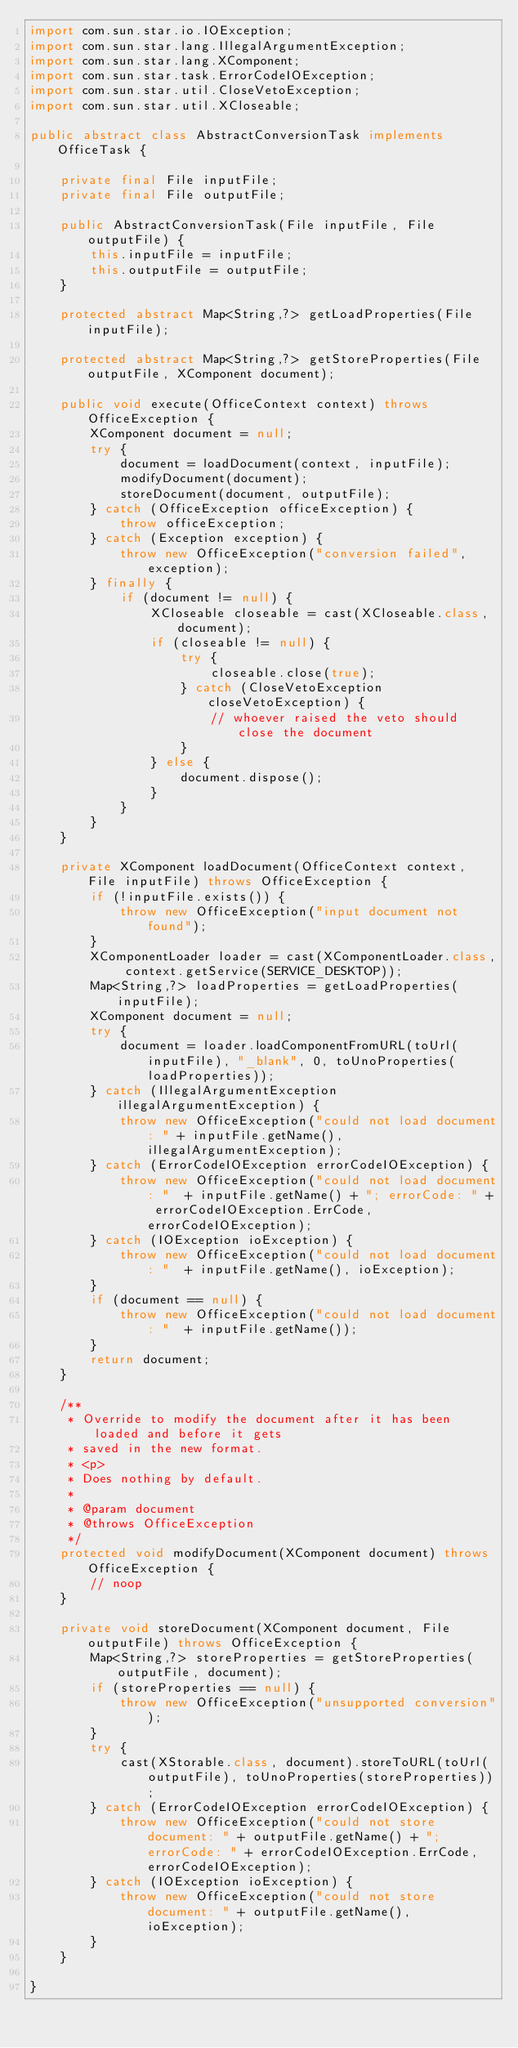<code> <loc_0><loc_0><loc_500><loc_500><_Java_>import com.sun.star.io.IOException;
import com.sun.star.lang.IllegalArgumentException;
import com.sun.star.lang.XComponent;
import com.sun.star.task.ErrorCodeIOException;
import com.sun.star.util.CloseVetoException;
import com.sun.star.util.XCloseable;

public abstract class AbstractConversionTask implements OfficeTask {

    private final File inputFile;
    private final File outputFile;

    public AbstractConversionTask(File inputFile, File outputFile) {
        this.inputFile = inputFile;
        this.outputFile = outputFile;
    }

    protected abstract Map<String,?> getLoadProperties(File inputFile);

    protected abstract Map<String,?> getStoreProperties(File outputFile, XComponent document);

    public void execute(OfficeContext context) throws OfficeException {
        XComponent document = null;
        try {
            document = loadDocument(context, inputFile);
            modifyDocument(document);
            storeDocument(document, outputFile);
        } catch (OfficeException officeException) {
            throw officeException;
        } catch (Exception exception) {
            throw new OfficeException("conversion failed", exception);
        } finally {
            if (document != null) {
                XCloseable closeable = cast(XCloseable.class, document);
                if (closeable != null) {
                    try {
                        closeable.close(true);
                    } catch (CloseVetoException closeVetoException) {
                        // whoever raised the veto should close the document
                    }
                } else {
                    document.dispose();
                }
            }
        }
    }

    private XComponent loadDocument(OfficeContext context, File inputFile) throws OfficeException {
        if (!inputFile.exists()) {
            throw new OfficeException("input document not found");
        }
        XComponentLoader loader = cast(XComponentLoader.class, context.getService(SERVICE_DESKTOP));
        Map<String,?> loadProperties = getLoadProperties(inputFile);
        XComponent document = null;
        try {
            document = loader.loadComponentFromURL(toUrl(inputFile), "_blank", 0, toUnoProperties(loadProperties));
        } catch (IllegalArgumentException illegalArgumentException) {
            throw new OfficeException("could not load document: " + inputFile.getName(), illegalArgumentException);
        } catch (ErrorCodeIOException errorCodeIOException) {
            throw new OfficeException("could not load document: "  + inputFile.getName() + "; errorCode: " + errorCodeIOException.ErrCode, errorCodeIOException);
        } catch (IOException ioException) {
            throw new OfficeException("could not load document: "  + inputFile.getName(), ioException);
        }
        if (document == null) {
            throw new OfficeException("could not load document: "  + inputFile.getName());
        }
        return document;
    }

    /**
     * Override to modify the document after it has been loaded and before it gets
     * saved in the new format.
     * <p>
     * Does nothing by default.
     * 
     * @param document
     * @throws OfficeException
     */
    protected void modifyDocument(XComponent document) throws OfficeException {
    	// noop
    }

    private void storeDocument(XComponent document, File outputFile) throws OfficeException {
        Map<String,?> storeProperties = getStoreProperties(outputFile, document);
        if (storeProperties == null) {
            throw new OfficeException("unsupported conversion");
        }
        try {
            cast(XStorable.class, document).storeToURL(toUrl(outputFile), toUnoProperties(storeProperties));
        } catch (ErrorCodeIOException errorCodeIOException) {
            throw new OfficeException("could not store document: " + outputFile.getName() + "; errorCode: " + errorCodeIOException.ErrCode, errorCodeIOException);
        } catch (IOException ioException) {
            throw new OfficeException("could not store document: " + outputFile.getName(), ioException);
        }
    }

}
</code> 